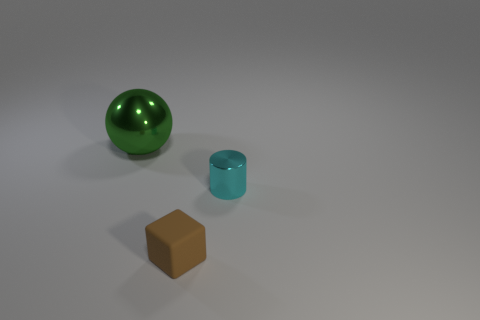Add 2 spheres. How many objects exist? 5 Subtract all balls. How many objects are left? 2 Add 2 blocks. How many blocks are left? 3 Add 1 small cyan matte cylinders. How many small cyan matte cylinders exist? 1 Subtract 0 brown balls. How many objects are left? 3 Subtract all green shiny cylinders. Subtract all cyan metallic objects. How many objects are left? 2 